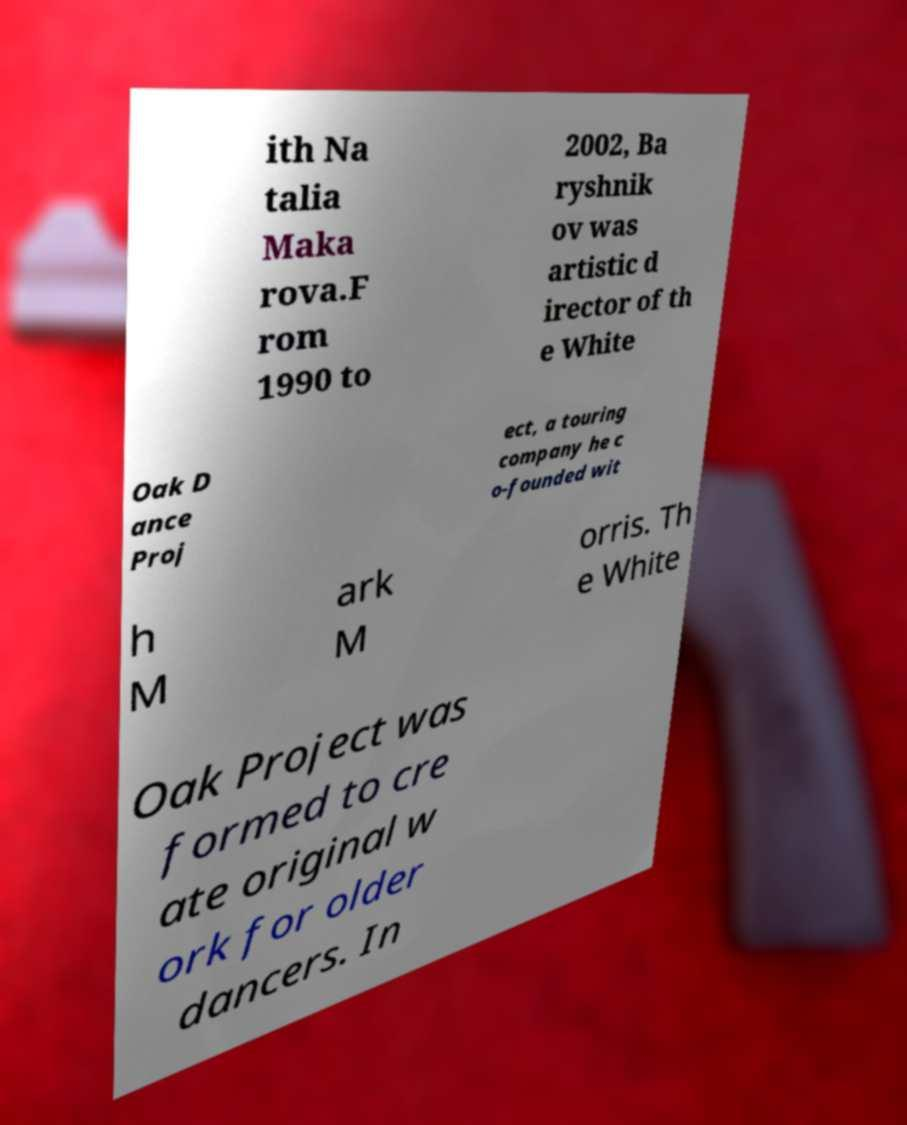Could you extract and type out the text from this image? ith Na talia Maka rova.F rom 1990 to 2002, Ba ryshnik ov was artistic d irector of th e White Oak D ance Proj ect, a touring company he c o-founded wit h M ark M orris. Th e White Oak Project was formed to cre ate original w ork for older dancers. In 